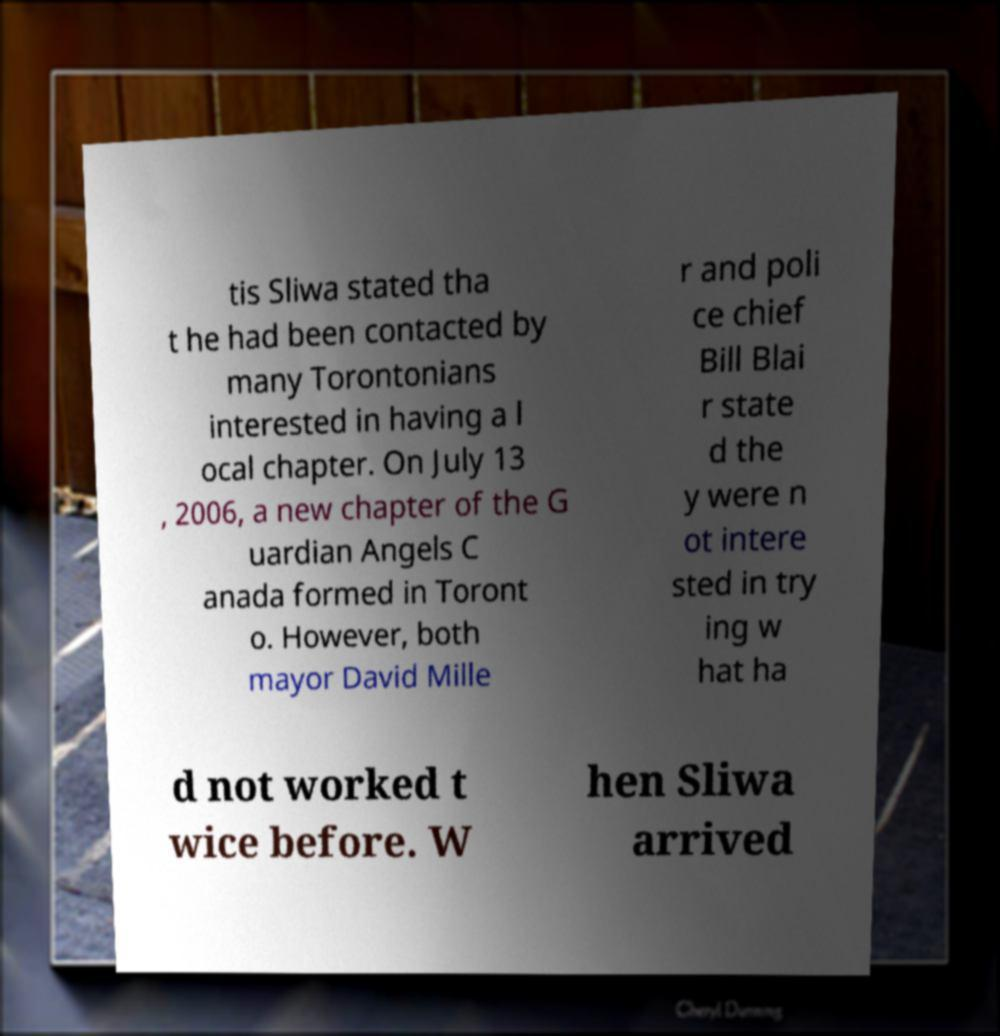Please identify and transcribe the text found in this image. tis Sliwa stated tha t he had been contacted by many Torontonians interested in having a l ocal chapter. On July 13 , 2006, a new chapter of the G uardian Angels C anada formed in Toront o. However, both mayor David Mille r and poli ce chief Bill Blai r state d the y were n ot intere sted in try ing w hat ha d not worked t wice before. W hen Sliwa arrived 